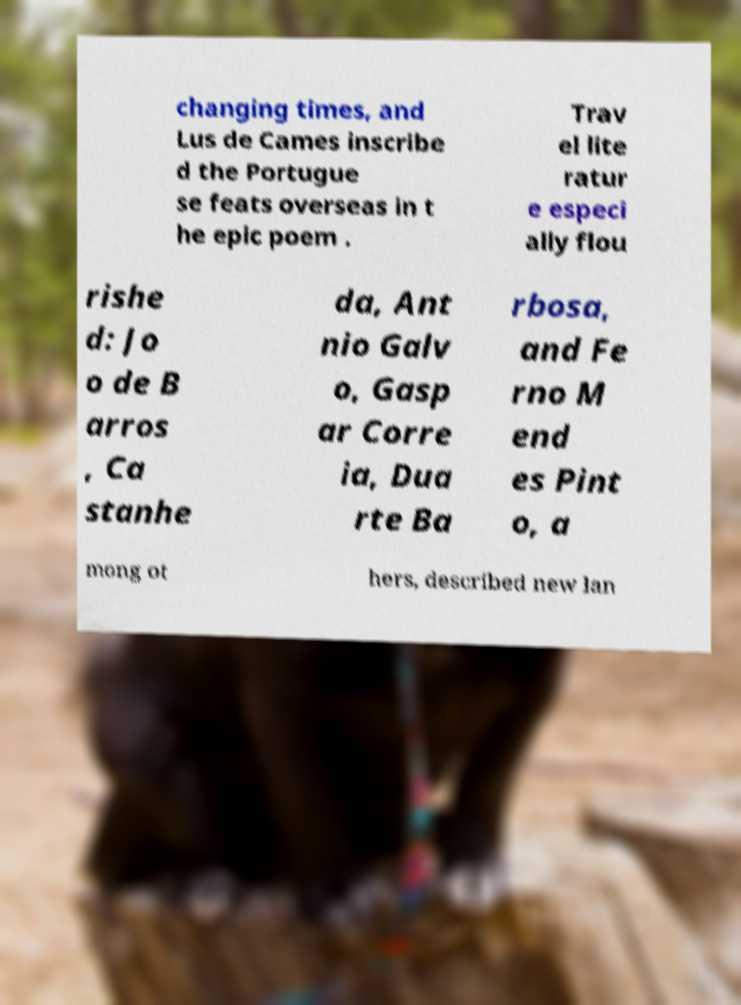I need the written content from this picture converted into text. Can you do that? changing times, and Lus de Cames inscribe d the Portugue se feats overseas in t he epic poem . Trav el lite ratur e especi ally flou rishe d: Jo o de B arros , Ca stanhe da, Ant nio Galv o, Gasp ar Corre ia, Dua rte Ba rbosa, and Fe rno M end es Pint o, a mong ot hers, described new lan 